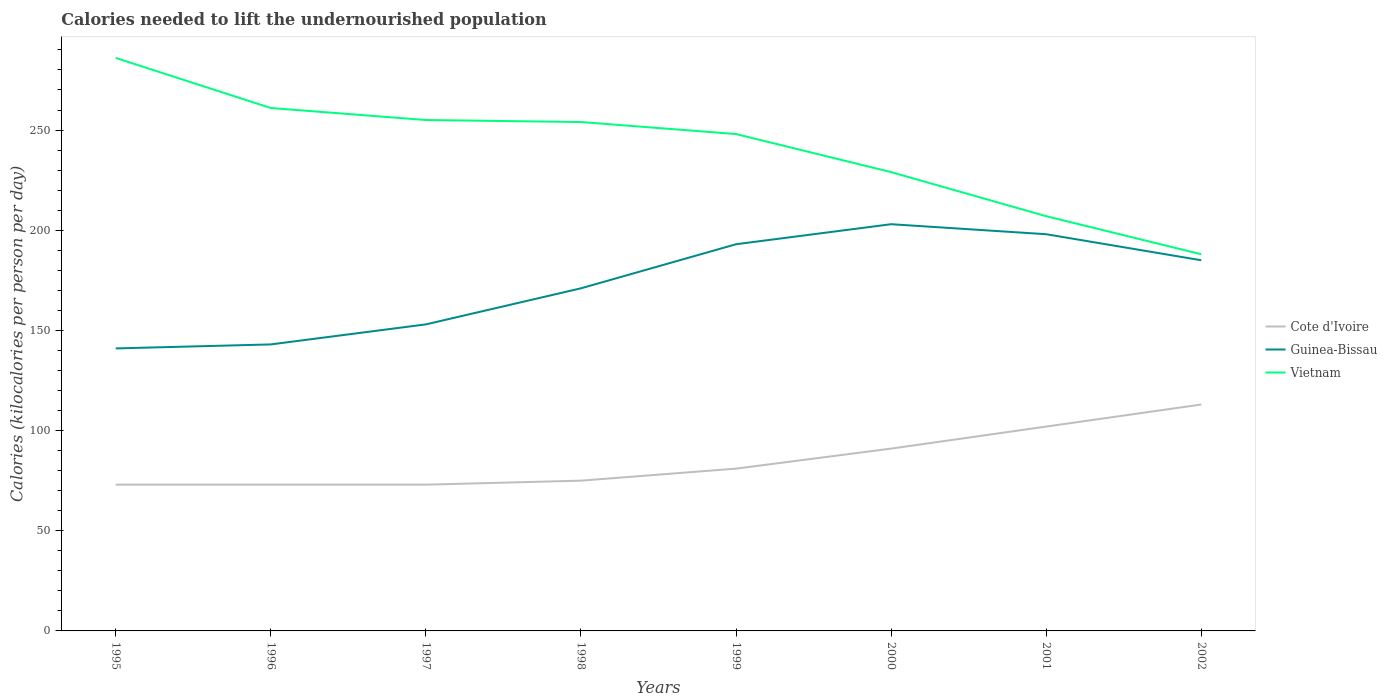How many different coloured lines are there?
Ensure brevity in your answer.  3. Does the line corresponding to Guinea-Bissau intersect with the line corresponding to Vietnam?
Provide a succinct answer. No. Across all years, what is the maximum total calories needed to lift the undernourished population in Vietnam?
Provide a short and direct response. 188. What is the total total calories needed to lift the undernourished population in Cote d'Ivoire in the graph?
Provide a short and direct response. -8. What is the difference between the highest and the second highest total calories needed to lift the undernourished population in Cote d'Ivoire?
Ensure brevity in your answer.  40. Is the total calories needed to lift the undernourished population in Cote d'Ivoire strictly greater than the total calories needed to lift the undernourished population in Vietnam over the years?
Offer a very short reply. Yes. How many lines are there?
Your answer should be compact. 3. What is the difference between two consecutive major ticks on the Y-axis?
Provide a short and direct response. 50. Are the values on the major ticks of Y-axis written in scientific E-notation?
Keep it short and to the point. No. Does the graph contain any zero values?
Keep it short and to the point. No. Where does the legend appear in the graph?
Your response must be concise. Center right. How many legend labels are there?
Provide a succinct answer. 3. How are the legend labels stacked?
Your answer should be very brief. Vertical. What is the title of the graph?
Your answer should be compact. Calories needed to lift the undernourished population. Does "Congo (Republic)" appear as one of the legend labels in the graph?
Provide a short and direct response. No. What is the label or title of the Y-axis?
Your answer should be compact. Calories (kilocalories per person per day). What is the Calories (kilocalories per person per day) in Cote d'Ivoire in 1995?
Keep it short and to the point. 73. What is the Calories (kilocalories per person per day) of Guinea-Bissau in 1995?
Your response must be concise. 141. What is the Calories (kilocalories per person per day) of Vietnam in 1995?
Ensure brevity in your answer.  286. What is the Calories (kilocalories per person per day) of Cote d'Ivoire in 1996?
Provide a succinct answer. 73. What is the Calories (kilocalories per person per day) of Guinea-Bissau in 1996?
Offer a terse response. 143. What is the Calories (kilocalories per person per day) of Vietnam in 1996?
Ensure brevity in your answer.  261. What is the Calories (kilocalories per person per day) in Guinea-Bissau in 1997?
Your answer should be very brief. 153. What is the Calories (kilocalories per person per day) in Vietnam in 1997?
Offer a terse response. 255. What is the Calories (kilocalories per person per day) in Guinea-Bissau in 1998?
Ensure brevity in your answer.  171. What is the Calories (kilocalories per person per day) of Vietnam in 1998?
Offer a very short reply. 254. What is the Calories (kilocalories per person per day) in Cote d'Ivoire in 1999?
Provide a short and direct response. 81. What is the Calories (kilocalories per person per day) in Guinea-Bissau in 1999?
Offer a terse response. 193. What is the Calories (kilocalories per person per day) of Vietnam in 1999?
Your answer should be compact. 248. What is the Calories (kilocalories per person per day) of Cote d'Ivoire in 2000?
Make the answer very short. 91. What is the Calories (kilocalories per person per day) of Guinea-Bissau in 2000?
Your answer should be very brief. 203. What is the Calories (kilocalories per person per day) of Vietnam in 2000?
Make the answer very short. 229. What is the Calories (kilocalories per person per day) of Cote d'Ivoire in 2001?
Provide a succinct answer. 102. What is the Calories (kilocalories per person per day) of Guinea-Bissau in 2001?
Ensure brevity in your answer.  198. What is the Calories (kilocalories per person per day) of Vietnam in 2001?
Provide a succinct answer. 207. What is the Calories (kilocalories per person per day) in Cote d'Ivoire in 2002?
Keep it short and to the point. 113. What is the Calories (kilocalories per person per day) in Guinea-Bissau in 2002?
Make the answer very short. 185. What is the Calories (kilocalories per person per day) in Vietnam in 2002?
Offer a terse response. 188. Across all years, what is the maximum Calories (kilocalories per person per day) of Cote d'Ivoire?
Provide a succinct answer. 113. Across all years, what is the maximum Calories (kilocalories per person per day) of Guinea-Bissau?
Your answer should be very brief. 203. Across all years, what is the maximum Calories (kilocalories per person per day) of Vietnam?
Your answer should be compact. 286. Across all years, what is the minimum Calories (kilocalories per person per day) of Guinea-Bissau?
Your answer should be compact. 141. Across all years, what is the minimum Calories (kilocalories per person per day) of Vietnam?
Offer a very short reply. 188. What is the total Calories (kilocalories per person per day) of Cote d'Ivoire in the graph?
Make the answer very short. 681. What is the total Calories (kilocalories per person per day) of Guinea-Bissau in the graph?
Your answer should be very brief. 1387. What is the total Calories (kilocalories per person per day) of Vietnam in the graph?
Ensure brevity in your answer.  1928. What is the difference between the Calories (kilocalories per person per day) of Guinea-Bissau in 1995 and that in 1996?
Keep it short and to the point. -2. What is the difference between the Calories (kilocalories per person per day) of Cote d'Ivoire in 1995 and that in 1997?
Your answer should be very brief. 0. What is the difference between the Calories (kilocalories per person per day) of Guinea-Bissau in 1995 and that in 1998?
Offer a terse response. -30. What is the difference between the Calories (kilocalories per person per day) in Cote d'Ivoire in 1995 and that in 1999?
Give a very brief answer. -8. What is the difference between the Calories (kilocalories per person per day) of Guinea-Bissau in 1995 and that in 1999?
Give a very brief answer. -52. What is the difference between the Calories (kilocalories per person per day) in Vietnam in 1995 and that in 1999?
Your answer should be compact. 38. What is the difference between the Calories (kilocalories per person per day) of Guinea-Bissau in 1995 and that in 2000?
Provide a short and direct response. -62. What is the difference between the Calories (kilocalories per person per day) in Guinea-Bissau in 1995 and that in 2001?
Give a very brief answer. -57. What is the difference between the Calories (kilocalories per person per day) of Vietnam in 1995 and that in 2001?
Make the answer very short. 79. What is the difference between the Calories (kilocalories per person per day) of Guinea-Bissau in 1995 and that in 2002?
Your response must be concise. -44. What is the difference between the Calories (kilocalories per person per day) of Cote d'Ivoire in 1996 and that in 1997?
Your response must be concise. 0. What is the difference between the Calories (kilocalories per person per day) in Guinea-Bissau in 1996 and that in 1997?
Ensure brevity in your answer.  -10. What is the difference between the Calories (kilocalories per person per day) of Guinea-Bissau in 1996 and that in 1998?
Make the answer very short. -28. What is the difference between the Calories (kilocalories per person per day) of Vietnam in 1996 and that in 1998?
Make the answer very short. 7. What is the difference between the Calories (kilocalories per person per day) in Guinea-Bissau in 1996 and that in 1999?
Make the answer very short. -50. What is the difference between the Calories (kilocalories per person per day) in Guinea-Bissau in 1996 and that in 2000?
Ensure brevity in your answer.  -60. What is the difference between the Calories (kilocalories per person per day) in Vietnam in 1996 and that in 2000?
Your answer should be very brief. 32. What is the difference between the Calories (kilocalories per person per day) in Guinea-Bissau in 1996 and that in 2001?
Provide a short and direct response. -55. What is the difference between the Calories (kilocalories per person per day) in Cote d'Ivoire in 1996 and that in 2002?
Keep it short and to the point. -40. What is the difference between the Calories (kilocalories per person per day) in Guinea-Bissau in 1996 and that in 2002?
Offer a very short reply. -42. What is the difference between the Calories (kilocalories per person per day) of Cote d'Ivoire in 1997 and that in 1998?
Provide a succinct answer. -2. What is the difference between the Calories (kilocalories per person per day) in Vietnam in 1997 and that in 1998?
Your answer should be very brief. 1. What is the difference between the Calories (kilocalories per person per day) in Vietnam in 1997 and that in 1999?
Make the answer very short. 7. What is the difference between the Calories (kilocalories per person per day) of Vietnam in 1997 and that in 2000?
Your answer should be very brief. 26. What is the difference between the Calories (kilocalories per person per day) of Guinea-Bissau in 1997 and that in 2001?
Your answer should be compact. -45. What is the difference between the Calories (kilocalories per person per day) in Vietnam in 1997 and that in 2001?
Your answer should be very brief. 48. What is the difference between the Calories (kilocalories per person per day) in Cote d'Ivoire in 1997 and that in 2002?
Provide a short and direct response. -40. What is the difference between the Calories (kilocalories per person per day) in Guinea-Bissau in 1997 and that in 2002?
Your answer should be compact. -32. What is the difference between the Calories (kilocalories per person per day) of Vietnam in 1997 and that in 2002?
Offer a terse response. 67. What is the difference between the Calories (kilocalories per person per day) in Cote d'Ivoire in 1998 and that in 1999?
Your response must be concise. -6. What is the difference between the Calories (kilocalories per person per day) in Vietnam in 1998 and that in 1999?
Your answer should be very brief. 6. What is the difference between the Calories (kilocalories per person per day) of Cote d'Ivoire in 1998 and that in 2000?
Offer a terse response. -16. What is the difference between the Calories (kilocalories per person per day) of Guinea-Bissau in 1998 and that in 2000?
Keep it short and to the point. -32. What is the difference between the Calories (kilocalories per person per day) of Vietnam in 1998 and that in 2001?
Provide a short and direct response. 47. What is the difference between the Calories (kilocalories per person per day) of Cote d'Ivoire in 1998 and that in 2002?
Your answer should be very brief. -38. What is the difference between the Calories (kilocalories per person per day) in Guinea-Bissau in 1998 and that in 2002?
Give a very brief answer. -14. What is the difference between the Calories (kilocalories per person per day) in Cote d'Ivoire in 1999 and that in 2000?
Your answer should be very brief. -10. What is the difference between the Calories (kilocalories per person per day) of Vietnam in 1999 and that in 2000?
Your response must be concise. 19. What is the difference between the Calories (kilocalories per person per day) of Guinea-Bissau in 1999 and that in 2001?
Give a very brief answer. -5. What is the difference between the Calories (kilocalories per person per day) in Cote d'Ivoire in 1999 and that in 2002?
Ensure brevity in your answer.  -32. What is the difference between the Calories (kilocalories per person per day) in Guinea-Bissau in 1999 and that in 2002?
Your response must be concise. 8. What is the difference between the Calories (kilocalories per person per day) in Cote d'Ivoire in 2000 and that in 2001?
Provide a short and direct response. -11. What is the difference between the Calories (kilocalories per person per day) of Guinea-Bissau in 2000 and that in 2001?
Provide a short and direct response. 5. What is the difference between the Calories (kilocalories per person per day) of Cote d'Ivoire in 2000 and that in 2002?
Your answer should be compact. -22. What is the difference between the Calories (kilocalories per person per day) in Guinea-Bissau in 2000 and that in 2002?
Make the answer very short. 18. What is the difference between the Calories (kilocalories per person per day) in Vietnam in 2000 and that in 2002?
Your answer should be compact. 41. What is the difference between the Calories (kilocalories per person per day) of Vietnam in 2001 and that in 2002?
Offer a very short reply. 19. What is the difference between the Calories (kilocalories per person per day) in Cote d'Ivoire in 1995 and the Calories (kilocalories per person per day) in Guinea-Bissau in 1996?
Your answer should be very brief. -70. What is the difference between the Calories (kilocalories per person per day) of Cote d'Ivoire in 1995 and the Calories (kilocalories per person per day) of Vietnam in 1996?
Your response must be concise. -188. What is the difference between the Calories (kilocalories per person per day) of Guinea-Bissau in 1995 and the Calories (kilocalories per person per day) of Vietnam in 1996?
Your answer should be compact. -120. What is the difference between the Calories (kilocalories per person per day) of Cote d'Ivoire in 1995 and the Calories (kilocalories per person per day) of Guinea-Bissau in 1997?
Your answer should be very brief. -80. What is the difference between the Calories (kilocalories per person per day) in Cote d'Ivoire in 1995 and the Calories (kilocalories per person per day) in Vietnam in 1997?
Your answer should be compact. -182. What is the difference between the Calories (kilocalories per person per day) of Guinea-Bissau in 1995 and the Calories (kilocalories per person per day) of Vietnam in 1997?
Offer a terse response. -114. What is the difference between the Calories (kilocalories per person per day) in Cote d'Ivoire in 1995 and the Calories (kilocalories per person per day) in Guinea-Bissau in 1998?
Ensure brevity in your answer.  -98. What is the difference between the Calories (kilocalories per person per day) in Cote d'Ivoire in 1995 and the Calories (kilocalories per person per day) in Vietnam in 1998?
Provide a short and direct response. -181. What is the difference between the Calories (kilocalories per person per day) in Guinea-Bissau in 1995 and the Calories (kilocalories per person per day) in Vietnam in 1998?
Offer a terse response. -113. What is the difference between the Calories (kilocalories per person per day) of Cote d'Ivoire in 1995 and the Calories (kilocalories per person per day) of Guinea-Bissau in 1999?
Offer a terse response. -120. What is the difference between the Calories (kilocalories per person per day) of Cote d'Ivoire in 1995 and the Calories (kilocalories per person per day) of Vietnam in 1999?
Offer a very short reply. -175. What is the difference between the Calories (kilocalories per person per day) in Guinea-Bissau in 1995 and the Calories (kilocalories per person per day) in Vietnam in 1999?
Your answer should be compact. -107. What is the difference between the Calories (kilocalories per person per day) of Cote d'Ivoire in 1995 and the Calories (kilocalories per person per day) of Guinea-Bissau in 2000?
Give a very brief answer. -130. What is the difference between the Calories (kilocalories per person per day) in Cote d'Ivoire in 1995 and the Calories (kilocalories per person per day) in Vietnam in 2000?
Give a very brief answer. -156. What is the difference between the Calories (kilocalories per person per day) in Guinea-Bissau in 1995 and the Calories (kilocalories per person per day) in Vietnam in 2000?
Offer a terse response. -88. What is the difference between the Calories (kilocalories per person per day) in Cote d'Ivoire in 1995 and the Calories (kilocalories per person per day) in Guinea-Bissau in 2001?
Your answer should be very brief. -125. What is the difference between the Calories (kilocalories per person per day) in Cote d'Ivoire in 1995 and the Calories (kilocalories per person per day) in Vietnam in 2001?
Offer a terse response. -134. What is the difference between the Calories (kilocalories per person per day) in Guinea-Bissau in 1995 and the Calories (kilocalories per person per day) in Vietnam in 2001?
Provide a succinct answer. -66. What is the difference between the Calories (kilocalories per person per day) of Cote d'Ivoire in 1995 and the Calories (kilocalories per person per day) of Guinea-Bissau in 2002?
Your answer should be compact. -112. What is the difference between the Calories (kilocalories per person per day) in Cote d'Ivoire in 1995 and the Calories (kilocalories per person per day) in Vietnam in 2002?
Make the answer very short. -115. What is the difference between the Calories (kilocalories per person per day) of Guinea-Bissau in 1995 and the Calories (kilocalories per person per day) of Vietnam in 2002?
Your answer should be compact. -47. What is the difference between the Calories (kilocalories per person per day) of Cote d'Ivoire in 1996 and the Calories (kilocalories per person per day) of Guinea-Bissau in 1997?
Provide a short and direct response. -80. What is the difference between the Calories (kilocalories per person per day) in Cote d'Ivoire in 1996 and the Calories (kilocalories per person per day) in Vietnam in 1997?
Make the answer very short. -182. What is the difference between the Calories (kilocalories per person per day) in Guinea-Bissau in 1996 and the Calories (kilocalories per person per day) in Vietnam in 1997?
Your response must be concise. -112. What is the difference between the Calories (kilocalories per person per day) in Cote d'Ivoire in 1996 and the Calories (kilocalories per person per day) in Guinea-Bissau in 1998?
Your response must be concise. -98. What is the difference between the Calories (kilocalories per person per day) in Cote d'Ivoire in 1996 and the Calories (kilocalories per person per day) in Vietnam in 1998?
Your answer should be very brief. -181. What is the difference between the Calories (kilocalories per person per day) in Guinea-Bissau in 1996 and the Calories (kilocalories per person per day) in Vietnam in 1998?
Your response must be concise. -111. What is the difference between the Calories (kilocalories per person per day) of Cote d'Ivoire in 1996 and the Calories (kilocalories per person per day) of Guinea-Bissau in 1999?
Give a very brief answer. -120. What is the difference between the Calories (kilocalories per person per day) of Cote d'Ivoire in 1996 and the Calories (kilocalories per person per day) of Vietnam in 1999?
Provide a short and direct response. -175. What is the difference between the Calories (kilocalories per person per day) of Guinea-Bissau in 1996 and the Calories (kilocalories per person per day) of Vietnam in 1999?
Provide a short and direct response. -105. What is the difference between the Calories (kilocalories per person per day) in Cote d'Ivoire in 1996 and the Calories (kilocalories per person per day) in Guinea-Bissau in 2000?
Your answer should be compact. -130. What is the difference between the Calories (kilocalories per person per day) of Cote d'Ivoire in 1996 and the Calories (kilocalories per person per day) of Vietnam in 2000?
Offer a very short reply. -156. What is the difference between the Calories (kilocalories per person per day) in Guinea-Bissau in 1996 and the Calories (kilocalories per person per day) in Vietnam in 2000?
Offer a terse response. -86. What is the difference between the Calories (kilocalories per person per day) in Cote d'Ivoire in 1996 and the Calories (kilocalories per person per day) in Guinea-Bissau in 2001?
Offer a terse response. -125. What is the difference between the Calories (kilocalories per person per day) of Cote d'Ivoire in 1996 and the Calories (kilocalories per person per day) of Vietnam in 2001?
Provide a succinct answer. -134. What is the difference between the Calories (kilocalories per person per day) in Guinea-Bissau in 1996 and the Calories (kilocalories per person per day) in Vietnam in 2001?
Provide a succinct answer. -64. What is the difference between the Calories (kilocalories per person per day) in Cote d'Ivoire in 1996 and the Calories (kilocalories per person per day) in Guinea-Bissau in 2002?
Make the answer very short. -112. What is the difference between the Calories (kilocalories per person per day) of Cote d'Ivoire in 1996 and the Calories (kilocalories per person per day) of Vietnam in 2002?
Give a very brief answer. -115. What is the difference between the Calories (kilocalories per person per day) of Guinea-Bissau in 1996 and the Calories (kilocalories per person per day) of Vietnam in 2002?
Keep it short and to the point. -45. What is the difference between the Calories (kilocalories per person per day) of Cote d'Ivoire in 1997 and the Calories (kilocalories per person per day) of Guinea-Bissau in 1998?
Offer a terse response. -98. What is the difference between the Calories (kilocalories per person per day) of Cote d'Ivoire in 1997 and the Calories (kilocalories per person per day) of Vietnam in 1998?
Ensure brevity in your answer.  -181. What is the difference between the Calories (kilocalories per person per day) in Guinea-Bissau in 1997 and the Calories (kilocalories per person per day) in Vietnam in 1998?
Ensure brevity in your answer.  -101. What is the difference between the Calories (kilocalories per person per day) in Cote d'Ivoire in 1997 and the Calories (kilocalories per person per day) in Guinea-Bissau in 1999?
Your answer should be very brief. -120. What is the difference between the Calories (kilocalories per person per day) in Cote d'Ivoire in 1997 and the Calories (kilocalories per person per day) in Vietnam in 1999?
Make the answer very short. -175. What is the difference between the Calories (kilocalories per person per day) in Guinea-Bissau in 1997 and the Calories (kilocalories per person per day) in Vietnam in 1999?
Your response must be concise. -95. What is the difference between the Calories (kilocalories per person per day) in Cote d'Ivoire in 1997 and the Calories (kilocalories per person per day) in Guinea-Bissau in 2000?
Your response must be concise. -130. What is the difference between the Calories (kilocalories per person per day) in Cote d'Ivoire in 1997 and the Calories (kilocalories per person per day) in Vietnam in 2000?
Your response must be concise. -156. What is the difference between the Calories (kilocalories per person per day) in Guinea-Bissau in 1997 and the Calories (kilocalories per person per day) in Vietnam in 2000?
Make the answer very short. -76. What is the difference between the Calories (kilocalories per person per day) in Cote d'Ivoire in 1997 and the Calories (kilocalories per person per day) in Guinea-Bissau in 2001?
Keep it short and to the point. -125. What is the difference between the Calories (kilocalories per person per day) in Cote d'Ivoire in 1997 and the Calories (kilocalories per person per day) in Vietnam in 2001?
Make the answer very short. -134. What is the difference between the Calories (kilocalories per person per day) in Guinea-Bissau in 1997 and the Calories (kilocalories per person per day) in Vietnam in 2001?
Your response must be concise. -54. What is the difference between the Calories (kilocalories per person per day) in Cote d'Ivoire in 1997 and the Calories (kilocalories per person per day) in Guinea-Bissau in 2002?
Ensure brevity in your answer.  -112. What is the difference between the Calories (kilocalories per person per day) of Cote d'Ivoire in 1997 and the Calories (kilocalories per person per day) of Vietnam in 2002?
Your answer should be compact. -115. What is the difference between the Calories (kilocalories per person per day) of Guinea-Bissau in 1997 and the Calories (kilocalories per person per day) of Vietnam in 2002?
Your answer should be compact. -35. What is the difference between the Calories (kilocalories per person per day) in Cote d'Ivoire in 1998 and the Calories (kilocalories per person per day) in Guinea-Bissau in 1999?
Give a very brief answer. -118. What is the difference between the Calories (kilocalories per person per day) in Cote d'Ivoire in 1998 and the Calories (kilocalories per person per day) in Vietnam in 1999?
Offer a terse response. -173. What is the difference between the Calories (kilocalories per person per day) of Guinea-Bissau in 1998 and the Calories (kilocalories per person per day) of Vietnam in 1999?
Your answer should be very brief. -77. What is the difference between the Calories (kilocalories per person per day) of Cote d'Ivoire in 1998 and the Calories (kilocalories per person per day) of Guinea-Bissau in 2000?
Ensure brevity in your answer.  -128. What is the difference between the Calories (kilocalories per person per day) in Cote d'Ivoire in 1998 and the Calories (kilocalories per person per day) in Vietnam in 2000?
Your response must be concise. -154. What is the difference between the Calories (kilocalories per person per day) of Guinea-Bissau in 1998 and the Calories (kilocalories per person per day) of Vietnam in 2000?
Offer a very short reply. -58. What is the difference between the Calories (kilocalories per person per day) in Cote d'Ivoire in 1998 and the Calories (kilocalories per person per day) in Guinea-Bissau in 2001?
Ensure brevity in your answer.  -123. What is the difference between the Calories (kilocalories per person per day) in Cote d'Ivoire in 1998 and the Calories (kilocalories per person per day) in Vietnam in 2001?
Ensure brevity in your answer.  -132. What is the difference between the Calories (kilocalories per person per day) of Guinea-Bissau in 1998 and the Calories (kilocalories per person per day) of Vietnam in 2001?
Offer a very short reply. -36. What is the difference between the Calories (kilocalories per person per day) in Cote d'Ivoire in 1998 and the Calories (kilocalories per person per day) in Guinea-Bissau in 2002?
Your answer should be compact. -110. What is the difference between the Calories (kilocalories per person per day) of Cote d'Ivoire in 1998 and the Calories (kilocalories per person per day) of Vietnam in 2002?
Provide a short and direct response. -113. What is the difference between the Calories (kilocalories per person per day) in Cote d'Ivoire in 1999 and the Calories (kilocalories per person per day) in Guinea-Bissau in 2000?
Your response must be concise. -122. What is the difference between the Calories (kilocalories per person per day) of Cote d'Ivoire in 1999 and the Calories (kilocalories per person per day) of Vietnam in 2000?
Your answer should be compact. -148. What is the difference between the Calories (kilocalories per person per day) in Guinea-Bissau in 1999 and the Calories (kilocalories per person per day) in Vietnam in 2000?
Your answer should be compact. -36. What is the difference between the Calories (kilocalories per person per day) of Cote d'Ivoire in 1999 and the Calories (kilocalories per person per day) of Guinea-Bissau in 2001?
Your response must be concise. -117. What is the difference between the Calories (kilocalories per person per day) of Cote d'Ivoire in 1999 and the Calories (kilocalories per person per day) of Vietnam in 2001?
Provide a short and direct response. -126. What is the difference between the Calories (kilocalories per person per day) of Cote d'Ivoire in 1999 and the Calories (kilocalories per person per day) of Guinea-Bissau in 2002?
Provide a succinct answer. -104. What is the difference between the Calories (kilocalories per person per day) in Cote d'Ivoire in 1999 and the Calories (kilocalories per person per day) in Vietnam in 2002?
Give a very brief answer. -107. What is the difference between the Calories (kilocalories per person per day) of Guinea-Bissau in 1999 and the Calories (kilocalories per person per day) of Vietnam in 2002?
Make the answer very short. 5. What is the difference between the Calories (kilocalories per person per day) of Cote d'Ivoire in 2000 and the Calories (kilocalories per person per day) of Guinea-Bissau in 2001?
Offer a very short reply. -107. What is the difference between the Calories (kilocalories per person per day) of Cote d'Ivoire in 2000 and the Calories (kilocalories per person per day) of Vietnam in 2001?
Offer a terse response. -116. What is the difference between the Calories (kilocalories per person per day) in Cote d'Ivoire in 2000 and the Calories (kilocalories per person per day) in Guinea-Bissau in 2002?
Offer a terse response. -94. What is the difference between the Calories (kilocalories per person per day) in Cote d'Ivoire in 2000 and the Calories (kilocalories per person per day) in Vietnam in 2002?
Your answer should be very brief. -97. What is the difference between the Calories (kilocalories per person per day) of Guinea-Bissau in 2000 and the Calories (kilocalories per person per day) of Vietnam in 2002?
Offer a terse response. 15. What is the difference between the Calories (kilocalories per person per day) in Cote d'Ivoire in 2001 and the Calories (kilocalories per person per day) in Guinea-Bissau in 2002?
Give a very brief answer. -83. What is the difference between the Calories (kilocalories per person per day) in Cote d'Ivoire in 2001 and the Calories (kilocalories per person per day) in Vietnam in 2002?
Offer a terse response. -86. What is the average Calories (kilocalories per person per day) of Cote d'Ivoire per year?
Give a very brief answer. 85.12. What is the average Calories (kilocalories per person per day) of Guinea-Bissau per year?
Your response must be concise. 173.38. What is the average Calories (kilocalories per person per day) of Vietnam per year?
Provide a short and direct response. 241. In the year 1995, what is the difference between the Calories (kilocalories per person per day) in Cote d'Ivoire and Calories (kilocalories per person per day) in Guinea-Bissau?
Your answer should be very brief. -68. In the year 1995, what is the difference between the Calories (kilocalories per person per day) of Cote d'Ivoire and Calories (kilocalories per person per day) of Vietnam?
Offer a very short reply. -213. In the year 1995, what is the difference between the Calories (kilocalories per person per day) in Guinea-Bissau and Calories (kilocalories per person per day) in Vietnam?
Offer a terse response. -145. In the year 1996, what is the difference between the Calories (kilocalories per person per day) of Cote d'Ivoire and Calories (kilocalories per person per day) of Guinea-Bissau?
Offer a very short reply. -70. In the year 1996, what is the difference between the Calories (kilocalories per person per day) in Cote d'Ivoire and Calories (kilocalories per person per day) in Vietnam?
Ensure brevity in your answer.  -188. In the year 1996, what is the difference between the Calories (kilocalories per person per day) in Guinea-Bissau and Calories (kilocalories per person per day) in Vietnam?
Your response must be concise. -118. In the year 1997, what is the difference between the Calories (kilocalories per person per day) of Cote d'Ivoire and Calories (kilocalories per person per day) of Guinea-Bissau?
Your response must be concise. -80. In the year 1997, what is the difference between the Calories (kilocalories per person per day) of Cote d'Ivoire and Calories (kilocalories per person per day) of Vietnam?
Your answer should be very brief. -182. In the year 1997, what is the difference between the Calories (kilocalories per person per day) in Guinea-Bissau and Calories (kilocalories per person per day) in Vietnam?
Your response must be concise. -102. In the year 1998, what is the difference between the Calories (kilocalories per person per day) of Cote d'Ivoire and Calories (kilocalories per person per day) of Guinea-Bissau?
Provide a short and direct response. -96. In the year 1998, what is the difference between the Calories (kilocalories per person per day) in Cote d'Ivoire and Calories (kilocalories per person per day) in Vietnam?
Make the answer very short. -179. In the year 1998, what is the difference between the Calories (kilocalories per person per day) of Guinea-Bissau and Calories (kilocalories per person per day) of Vietnam?
Your answer should be very brief. -83. In the year 1999, what is the difference between the Calories (kilocalories per person per day) of Cote d'Ivoire and Calories (kilocalories per person per day) of Guinea-Bissau?
Give a very brief answer. -112. In the year 1999, what is the difference between the Calories (kilocalories per person per day) in Cote d'Ivoire and Calories (kilocalories per person per day) in Vietnam?
Offer a very short reply. -167. In the year 1999, what is the difference between the Calories (kilocalories per person per day) in Guinea-Bissau and Calories (kilocalories per person per day) in Vietnam?
Make the answer very short. -55. In the year 2000, what is the difference between the Calories (kilocalories per person per day) in Cote d'Ivoire and Calories (kilocalories per person per day) in Guinea-Bissau?
Your answer should be compact. -112. In the year 2000, what is the difference between the Calories (kilocalories per person per day) of Cote d'Ivoire and Calories (kilocalories per person per day) of Vietnam?
Offer a very short reply. -138. In the year 2001, what is the difference between the Calories (kilocalories per person per day) of Cote d'Ivoire and Calories (kilocalories per person per day) of Guinea-Bissau?
Provide a short and direct response. -96. In the year 2001, what is the difference between the Calories (kilocalories per person per day) of Cote d'Ivoire and Calories (kilocalories per person per day) of Vietnam?
Offer a terse response. -105. In the year 2002, what is the difference between the Calories (kilocalories per person per day) of Cote d'Ivoire and Calories (kilocalories per person per day) of Guinea-Bissau?
Ensure brevity in your answer.  -72. In the year 2002, what is the difference between the Calories (kilocalories per person per day) of Cote d'Ivoire and Calories (kilocalories per person per day) of Vietnam?
Keep it short and to the point. -75. What is the ratio of the Calories (kilocalories per person per day) of Cote d'Ivoire in 1995 to that in 1996?
Give a very brief answer. 1. What is the ratio of the Calories (kilocalories per person per day) in Guinea-Bissau in 1995 to that in 1996?
Offer a terse response. 0.99. What is the ratio of the Calories (kilocalories per person per day) in Vietnam in 1995 to that in 1996?
Offer a terse response. 1.1. What is the ratio of the Calories (kilocalories per person per day) of Cote d'Ivoire in 1995 to that in 1997?
Offer a terse response. 1. What is the ratio of the Calories (kilocalories per person per day) of Guinea-Bissau in 1995 to that in 1997?
Provide a succinct answer. 0.92. What is the ratio of the Calories (kilocalories per person per day) of Vietnam in 1995 to that in 1997?
Offer a very short reply. 1.12. What is the ratio of the Calories (kilocalories per person per day) of Cote d'Ivoire in 1995 to that in 1998?
Give a very brief answer. 0.97. What is the ratio of the Calories (kilocalories per person per day) of Guinea-Bissau in 1995 to that in 1998?
Offer a very short reply. 0.82. What is the ratio of the Calories (kilocalories per person per day) of Vietnam in 1995 to that in 1998?
Make the answer very short. 1.13. What is the ratio of the Calories (kilocalories per person per day) in Cote d'Ivoire in 1995 to that in 1999?
Ensure brevity in your answer.  0.9. What is the ratio of the Calories (kilocalories per person per day) of Guinea-Bissau in 1995 to that in 1999?
Your answer should be compact. 0.73. What is the ratio of the Calories (kilocalories per person per day) of Vietnam in 1995 to that in 1999?
Offer a very short reply. 1.15. What is the ratio of the Calories (kilocalories per person per day) in Cote d'Ivoire in 1995 to that in 2000?
Your answer should be very brief. 0.8. What is the ratio of the Calories (kilocalories per person per day) in Guinea-Bissau in 1995 to that in 2000?
Your response must be concise. 0.69. What is the ratio of the Calories (kilocalories per person per day) of Vietnam in 1995 to that in 2000?
Your answer should be very brief. 1.25. What is the ratio of the Calories (kilocalories per person per day) in Cote d'Ivoire in 1995 to that in 2001?
Provide a short and direct response. 0.72. What is the ratio of the Calories (kilocalories per person per day) in Guinea-Bissau in 1995 to that in 2001?
Keep it short and to the point. 0.71. What is the ratio of the Calories (kilocalories per person per day) in Vietnam in 1995 to that in 2001?
Your answer should be compact. 1.38. What is the ratio of the Calories (kilocalories per person per day) of Cote d'Ivoire in 1995 to that in 2002?
Provide a short and direct response. 0.65. What is the ratio of the Calories (kilocalories per person per day) in Guinea-Bissau in 1995 to that in 2002?
Make the answer very short. 0.76. What is the ratio of the Calories (kilocalories per person per day) in Vietnam in 1995 to that in 2002?
Make the answer very short. 1.52. What is the ratio of the Calories (kilocalories per person per day) in Cote d'Ivoire in 1996 to that in 1997?
Your answer should be very brief. 1. What is the ratio of the Calories (kilocalories per person per day) in Guinea-Bissau in 1996 to that in 1997?
Your answer should be compact. 0.93. What is the ratio of the Calories (kilocalories per person per day) of Vietnam in 1996 to that in 1997?
Ensure brevity in your answer.  1.02. What is the ratio of the Calories (kilocalories per person per day) of Cote d'Ivoire in 1996 to that in 1998?
Offer a very short reply. 0.97. What is the ratio of the Calories (kilocalories per person per day) of Guinea-Bissau in 1996 to that in 1998?
Your response must be concise. 0.84. What is the ratio of the Calories (kilocalories per person per day) of Vietnam in 1996 to that in 1998?
Your answer should be compact. 1.03. What is the ratio of the Calories (kilocalories per person per day) of Cote d'Ivoire in 1996 to that in 1999?
Your response must be concise. 0.9. What is the ratio of the Calories (kilocalories per person per day) in Guinea-Bissau in 1996 to that in 1999?
Your answer should be very brief. 0.74. What is the ratio of the Calories (kilocalories per person per day) in Vietnam in 1996 to that in 1999?
Your answer should be very brief. 1.05. What is the ratio of the Calories (kilocalories per person per day) of Cote d'Ivoire in 1996 to that in 2000?
Provide a short and direct response. 0.8. What is the ratio of the Calories (kilocalories per person per day) of Guinea-Bissau in 1996 to that in 2000?
Your answer should be very brief. 0.7. What is the ratio of the Calories (kilocalories per person per day) of Vietnam in 1996 to that in 2000?
Give a very brief answer. 1.14. What is the ratio of the Calories (kilocalories per person per day) in Cote d'Ivoire in 1996 to that in 2001?
Offer a very short reply. 0.72. What is the ratio of the Calories (kilocalories per person per day) in Guinea-Bissau in 1996 to that in 2001?
Offer a very short reply. 0.72. What is the ratio of the Calories (kilocalories per person per day) in Vietnam in 1996 to that in 2001?
Make the answer very short. 1.26. What is the ratio of the Calories (kilocalories per person per day) of Cote d'Ivoire in 1996 to that in 2002?
Your answer should be compact. 0.65. What is the ratio of the Calories (kilocalories per person per day) of Guinea-Bissau in 1996 to that in 2002?
Your response must be concise. 0.77. What is the ratio of the Calories (kilocalories per person per day) of Vietnam in 1996 to that in 2002?
Provide a succinct answer. 1.39. What is the ratio of the Calories (kilocalories per person per day) of Cote d'Ivoire in 1997 to that in 1998?
Give a very brief answer. 0.97. What is the ratio of the Calories (kilocalories per person per day) in Guinea-Bissau in 1997 to that in 1998?
Offer a very short reply. 0.89. What is the ratio of the Calories (kilocalories per person per day) in Cote d'Ivoire in 1997 to that in 1999?
Your answer should be very brief. 0.9. What is the ratio of the Calories (kilocalories per person per day) in Guinea-Bissau in 1997 to that in 1999?
Give a very brief answer. 0.79. What is the ratio of the Calories (kilocalories per person per day) of Vietnam in 1997 to that in 1999?
Keep it short and to the point. 1.03. What is the ratio of the Calories (kilocalories per person per day) in Cote d'Ivoire in 1997 to that in 2000?
Make the answer very short. 0.8. What is the ratio of the Calories (kilocalories per person per day) in Guinea-Bissau in 1997 to that in 2000?
Your answer should be compact. 0.75. What is the ratio of the Calories (kilocalories per person per day) of Vietnam in 1997 to that in 2000?
Your answer should be compact. 1.11. What is the ratio of the Calories (kilocalories per person per day) of Cote d'Ivoire in 1997 to that in 2001?
Give a very brief answer. 0.72. What is the ratio of the Calories (kilocalories per person per day) in Guinea-Bissau in 1997 to that in 2001?
Offer a very short reply. 0.77. What is the ratio of the Calories (kilocalories per person per day) in Vietnam in 1997 to that in 2001?
Your answer should be compact. 1.23. What is the ratio of the Calories (kilocalories per person per day) in Cote d'Ivoire in 1997 to that in 2002?
Provide a short and direct response. 0.65. What is the ratio of the Calories (kilocalories per person per day) of Guinea-Bissau in 1997 to that in 2002?
Make the answer very short. 0.83. What is the ratio of the Calories (kilocalories per person per day) in Vietnam in 1997 to that in 2002?
Make the answer very short. 1.36. What is the ratio of the Calories (kilocalories per person per day) in Cote d'Ivoire in 1998 to that in 1999?
Your response must be concise. 0.93. What is the ratio of the Calories (kilocalories per person per day) in Guinea-Bissau in 1998 to that in 1999?
Give a very brief answer. 0.89. What is the ratio of the Calories (kilocalories per person per day) in Vietnam in 1998 to that in 1999?
Provide a succinct answer. 1.02. What is the ratio of the Calories (kilocalories per person per day) of Cote d'Ivoire in 1998 to that in 2000?
Provide a short and direct response. 0.82. What is the ratio of the Calories (kilocalories per person per day) of Guinea-Bissau in 1998 to that in 2000?
Give a very brief answer. 0.84. What is the ratio of the Calories (kilocalories per person per day) of Vietnam in 1998 to that in 2000?
Your answer should be compact. 1.11. What is the ratio of the Calories (kilocalories per person per day) of Cote d'Ivoire in 1998 to that in 2001?
Your answer should be compact. 0.74. What is the ratio of the Calories (kilocalories per person per day) in Guinea-Bissau in 1998 to that in 2001?
Provide a succinct answer. 0.86. What is the ratio of the Calories (kilocalories per person per day) in Vietnam in 1998 to that in 2001?
Provide a succinct answer. 1.23. What is the ratio of the Calories (kilocalories per person per day) in Cote d'Ivoire in 1998 to that in 2002?
Provide a short and direct response. 0.66. What is the ratio of the Calories (kilocalories per person per day) of Guinea-Bissau in 1998 to that in 2002?
Offer a very short reply. 0.92. What is the ratio of the Calories (kilocalories per person per day) of Vietnam in 1998 to that in 2002?
Offer a very short reply. 1.35. What is the ratio of the Calories (kilocalories per person per day) of Cote d'Ivoire in 1999 to that in 2000?
Provide a short and direct response. 0.89. What is the ratio of the Calories (kilocalories per person per day) in Guinea-Bissau in 1999 to that in 2000?
Your answer should be compact. 0.95. What is the ratio of the Calories (kilocalories per person per day) of Vietnam in 1999 to that in 2000?
Provide a succinct answer. 1.08. What is the ratio of the Calories (kilocalories per person per day) of Cote d'Ivoire in 1999 to that in 2001?
Ensure brevity in your answer.  0.79. What is the ratio of the Calories (kilocalories per person per day) in Guinea-Bissau in 1999 to that in 2001?
Offer a very short reply. 0.97. What is the ratio of the Calories (kilocalories per person per day) in Vietnam in 1999 to that in 2001?
Make the answer very short. 1.2. What is the ratio of the Calories (kilocalories per person per day) of Cote d'Ivoire in 1999 to that in 2002?
Your response must be concise. 0.72. What is the ratio of the Calories (kilocalories per person per day) in Guinea-Bissau in 1999 to that in 2002?
Give a very brief answer. 1.04. What is the ratio of the Calories (kilocalories per person per day) in Vietnam in 1999 to that in 2002?
Your answer should be very brief. 1.32. What is the ratio of the Calories (kilocalories per person per day) in Cote d'Ivoire in 2000 to that in 2001?
Your response must be concise. 0.89. What is the ratio of the Calories (kilocalories per person per day) in Guinea-Bissau in 2000 to that in 2001?
Ensure brevity in your answer.  1.03. What is the ratio of the Calories (kilocalories per person per day) of Vietnam in 2000 to that in 2001?
Your answer should be compact. 1.11. What is the ratio of the Calories (kilocalories per person per day) in Cote d'Ivoire in 2000 to that in 2002?
Offer a very short reply. 0.81. What is the ratio of the Calories (kilocalories per person per day) of Guinea-Bissau in 2000 to that in 2002?
Your answer should be compact. 1.1. What is the ratio of the Calories (kilocalories per person per day) of Vietnam in 2000 to that in 2002?
Make the answer very short. 1.22. What is the ratio of the Calories (kilocalories per person per day) in Cote d'Ivoire in 2001 to that in 2002?
Offer a terse response. 0.9. What is the ratio of the Calories (kilocalories per person per day) in Guinea-Bissau in 2001 to that in 2002?
Give a very brief answer. 1.07. What is the ratio of the Calories (kilocalories per person per day) in Vietnam in 2001 to that in 2002?
Your answer should be very brief. 1.1. What is the difference between the highest and the second highest Calories (kilocalories per person per day) in Guinea-Bissau?
Your response must be concise. 5. What is the difference between the highest and the second highest Calories (kilocalories per person per day) in Vietnam?
Your answer should be very brief. 25. What is the difference between the highest and the lowest Calories (kilocalories per person per day) of Cote d'Ivoire?
Offer a terse response. 40. What is the difference between the highest and the lowest Calories (kilocalories per person per day) of Guinea-Bissau?
Your answer should be compact. 62. 